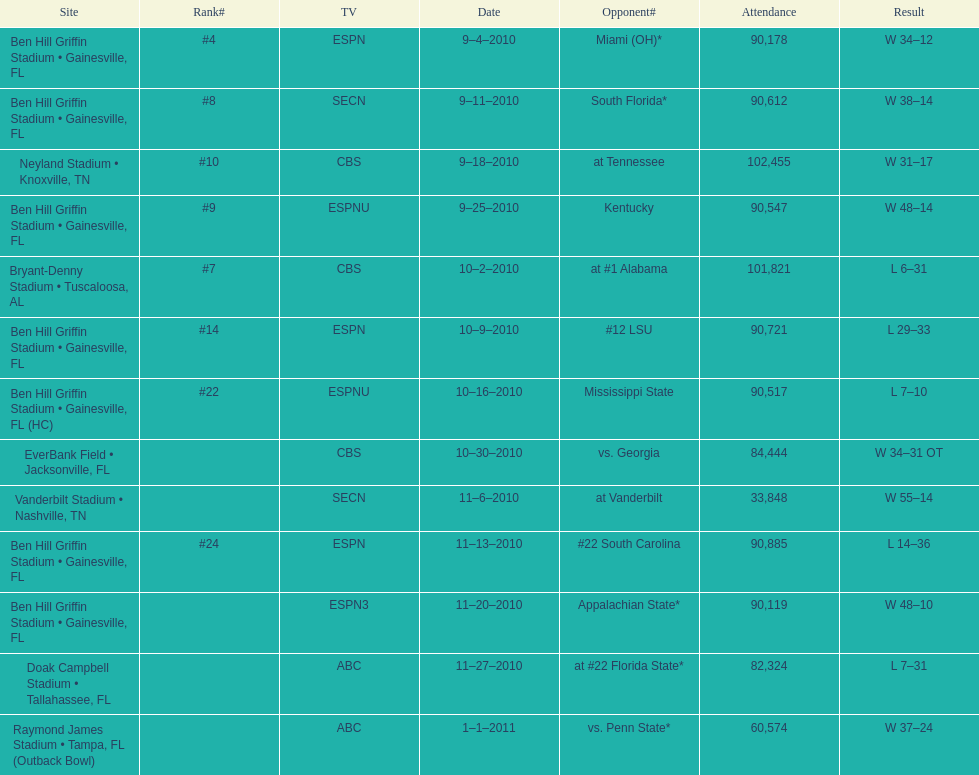What was the most the university of florida won by? 41 points. 